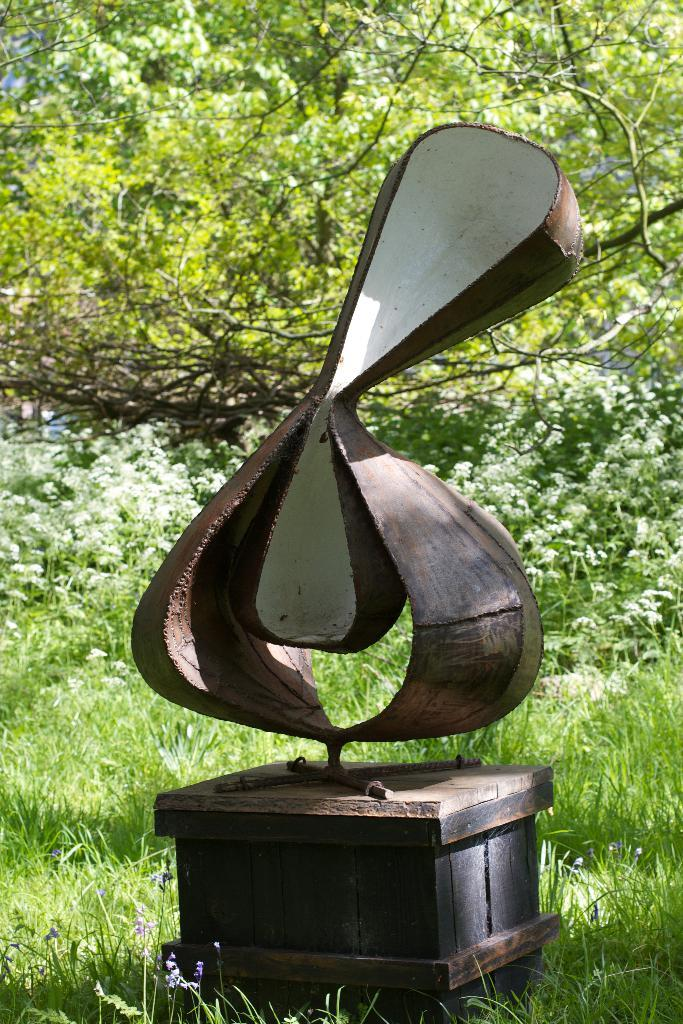What is the main subject in the image? There is a sculpture in the image. Where is the sculpture placed? The sculpture is on a box-shaped object. What is the box-shaped object placed on? The box-shaped object is placed on the grass. What type of vegetation can be seen in the image? There are grass plants and other plants in the image. What type of waste can be seen in the image? There is no waste visible in the image. Are there any pests present in the image? There is no indication of pests in the image. 